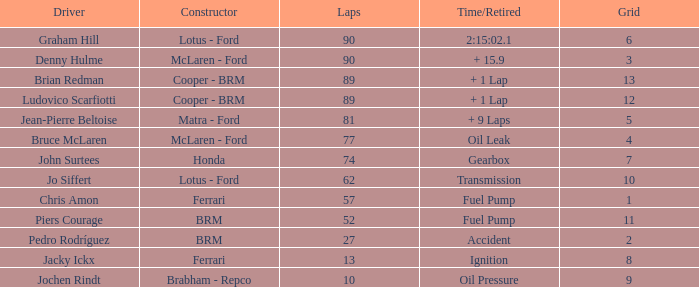At 52 laps, what is the corresponding time/retired situation? Fuel Pump. 